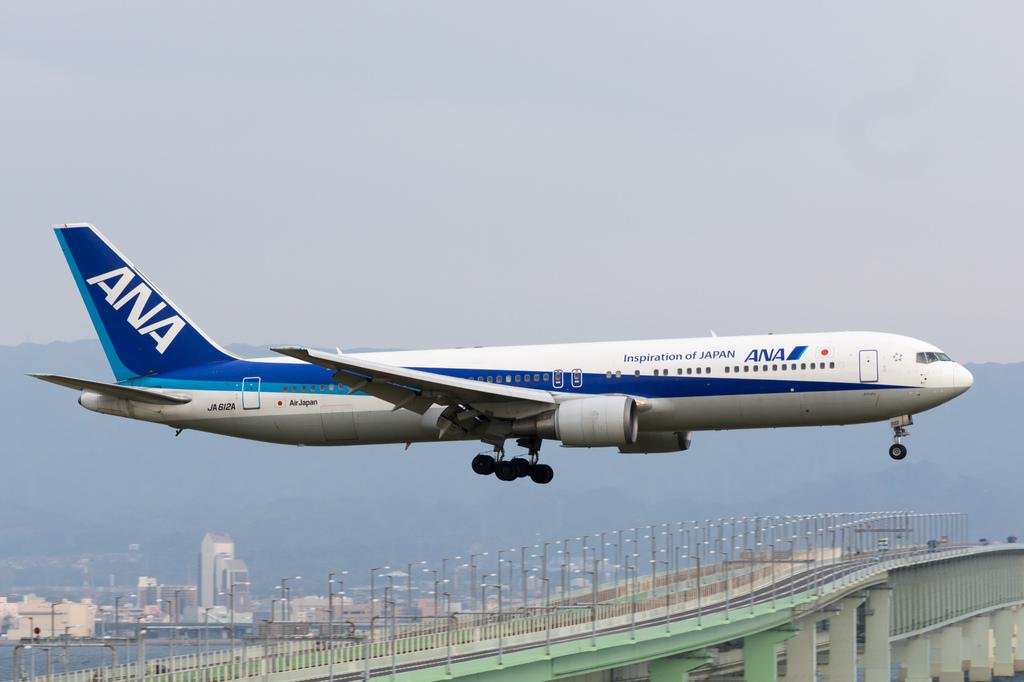What is the main subject of the image? The main subject of the image is an airplane. What is the airplane doing in the image? The airplane is flying in the air. What can be seen in the background of the image? There are street lights, buildings, a bridge, and other objects in the background of the image. What part of the sky is visible in the image? The sky is visible in the background of the image. What type of experience does the mouth have in the image? There is no mouth present in the image, so it is not possible to determine any experience related to a mouth. 